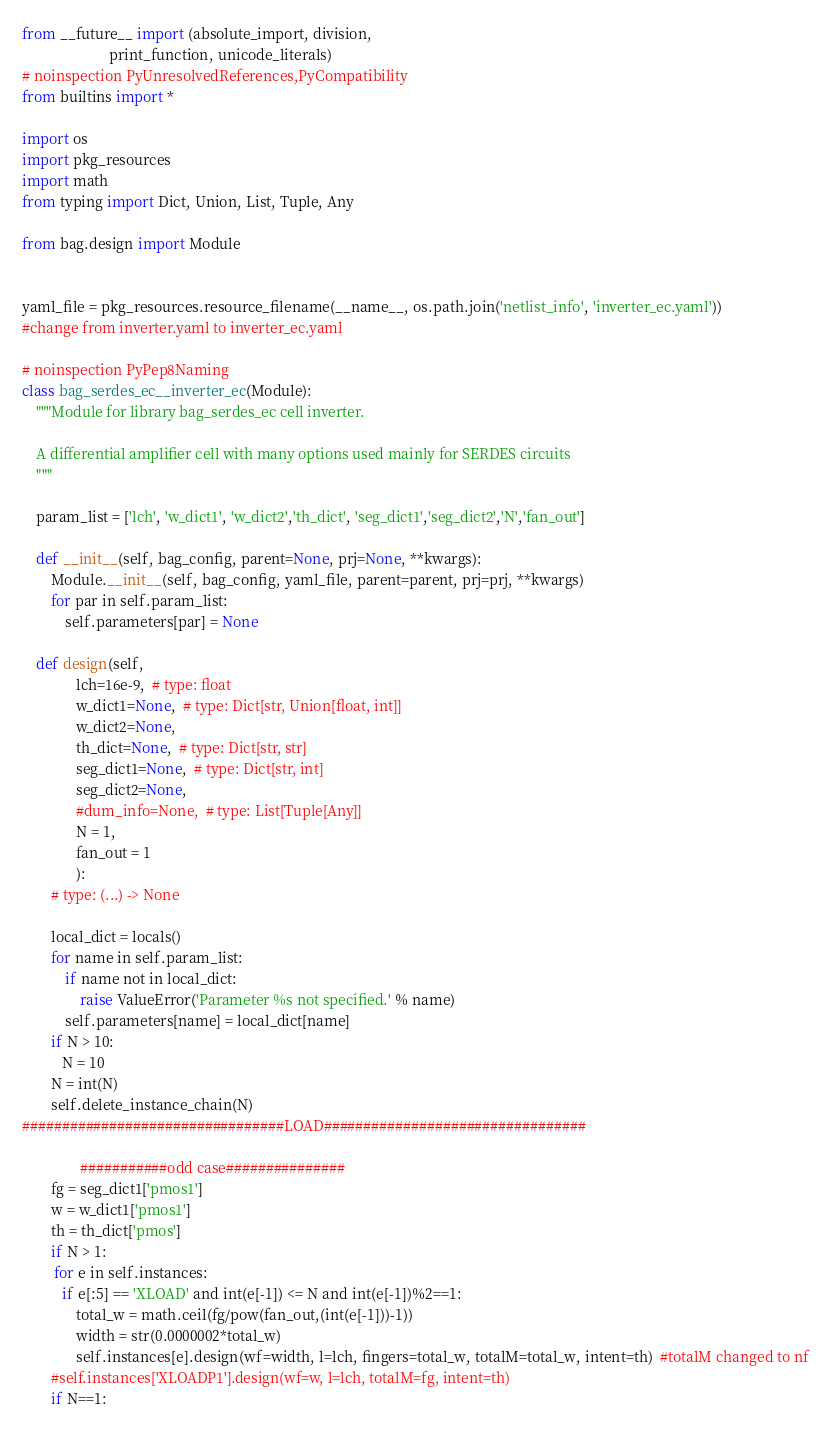<code> <loc_0><loc_0><loc_500><loc_500><_Python_>
from __future__ import (absolute_import, division,
                        print_function, unicode_literals)
# noinspection PyUnresolvedReferences,PyCompatibility
from builtins import *

import os
import pkg_resources
import math
from typing import Dict, Union, List, Tuple, Any

from bag.design import Module


yaml_file = pkg_resources.resource_filename(__name__, os.path.join('netlist_info', 'inverter_ec.yaml'))
#change from inverter.yaml to inverter_ec.yaml

# noinspection PyPep8Naming
class bag_serdes_ec__inverter_ec(Module):
    """Module for library bag_serdes_ec cell inverter.

    A differential amplifier cell with many options used mainly for SERDES circuits
    """

    param_list = ['lch', 'w_dict1', 'w_dict2','th_dict', 'seg_dict1','seg_dict2','N','fan_out']

    def __init__(self, bag_config, parent=None, prj=None, **kwargs):
        Module.__init__(self, bag_config, yaml_file, parent=parent, prj=prj, **kwargs)
        for par in self.param_list:
            self.parameters[par] = None

    def design(self,
               lch=16e-9,  # type: float
               w_dict1=None,  # type: Dict[str, Union[float, int]]
               w_dict2=None,
               th_dict=None,  # type: Dict[str, str]
               seg_dict1=None,  # type: Dict[str, int]
               seg_dict2=None,
               #dum_info=None,  # type: List[Tuple[Any]]
               N = 1,
               fan_out = 1
               ):
        # type: (...) -> None

        local_dict = locals()
        for name in self.param_list:
            if name not in local_dict:
                raise ValueError('Parameter %s not specified.' % name)
            self.parameters[name] = local_dict[name]
        if N > 10:
           N = 10
        N = int(N)
        self.delete_instance_chain(N)
#################################LOAD#################################  
 
                ###########odd case###############
        fg = seg_dict1['pmos1']
        w = w_dict1['pmos1']
        th = th_dict['pmos']
        if N > 1:
         for e in self.instances:
           if e[:5] == 'XLOAD' and int(e[-1]) <= N and int(e[-1])%2==1:
               total_w = math.ceil(fg/pow(fan_out,(int(e[-1]))-1))
               width = str(0.0000002*total_w)
               self.instances[e].design(wf=width, l=lch, fingers=total_w, totalM=total_w, intent=th)  #totalM changed to nf
        #self.instances['XLOADP1'].design(wf=w, l=lch, totalM=fg, intent=th)
        if N==1:</code> 